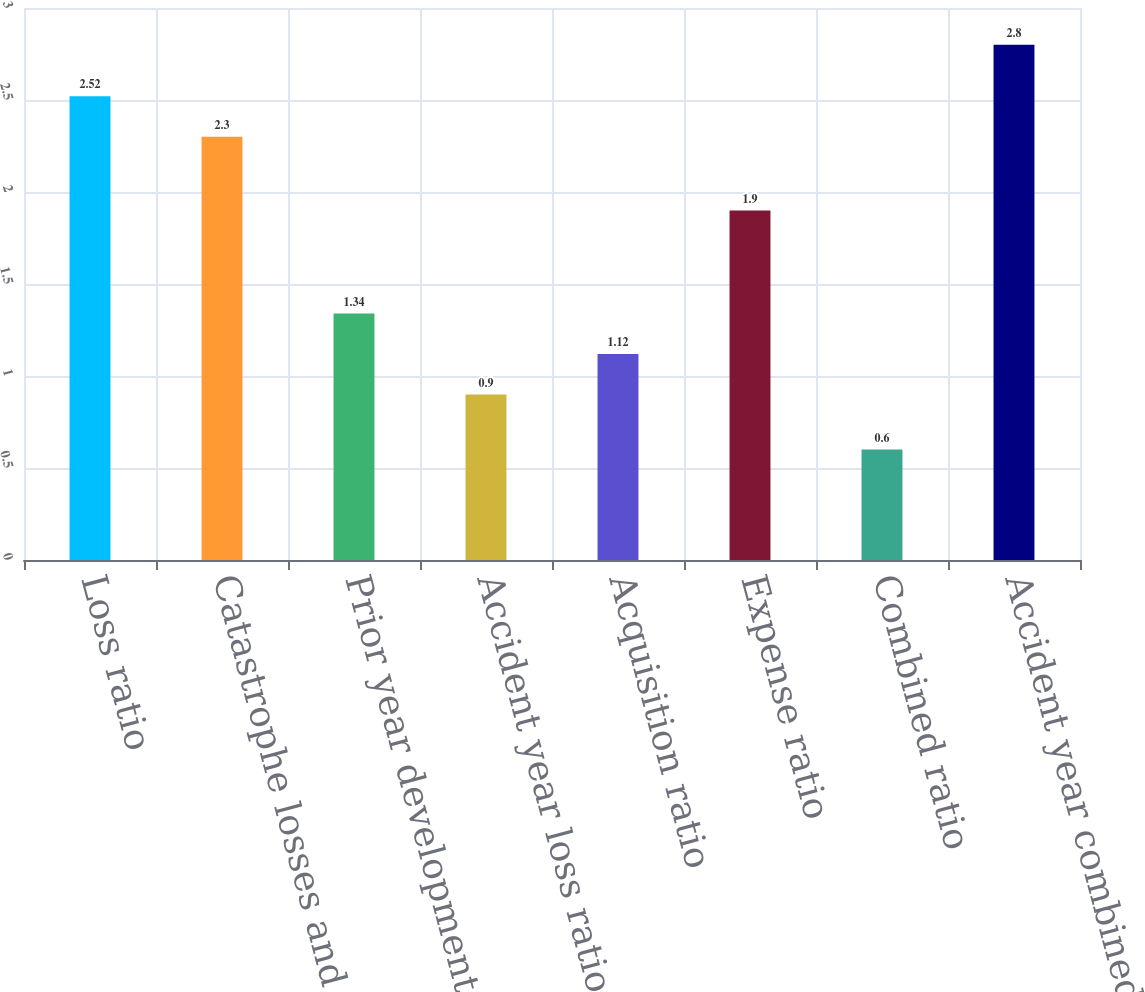Convert chart to OTSL. <chart><loc_0><loc_0><loc_500><loc_500><bar_chart><fcel>Loss ratio<fcel>Catastrophe losses and<fcel>Prior year development net of<fcel>Accident year loss ratio as<fcel>Acquisition ratio<fcel>Expense ratio<fcel>Combined ratio<fcel>Accident year combined ratio<nl><fcel>2.52<fcel>2.3<fcel>1.34<fcel>0.9<fcel>1.12<fcel>1.9<fcel>0.6<fcel>2.8<nl></chart> 